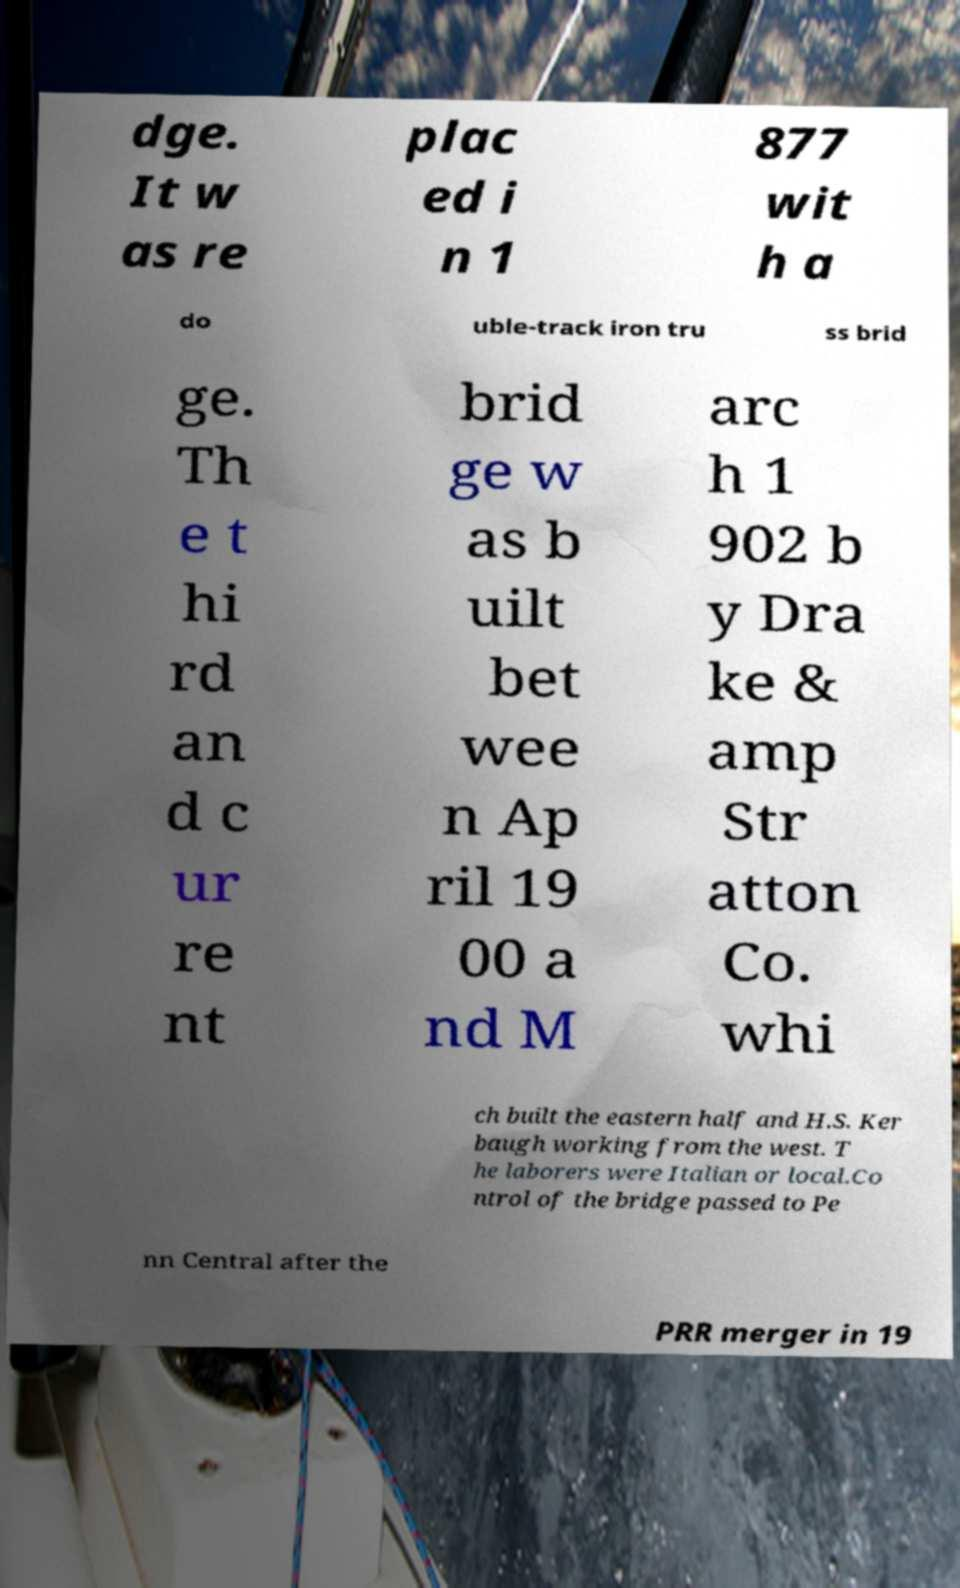I need the written content from this picture converted into text. Can you do that? dge. It w as re plac ed i n 1 877 wit h a do uble-track iron tru ss brid ge. Th e t hi rd an d c ur re nt brid ge w as b uilt bet wee n Ap ril 19 00 a nd M arc h 1 902 b y Dra ke & amp Str atton Co. whi ch built the eastern half and H.S. Ker baugh working from the west. T he laborers were Italian or local.Co ntrol of the bridge passed to Pe nn Central after the PRR merger in 19 